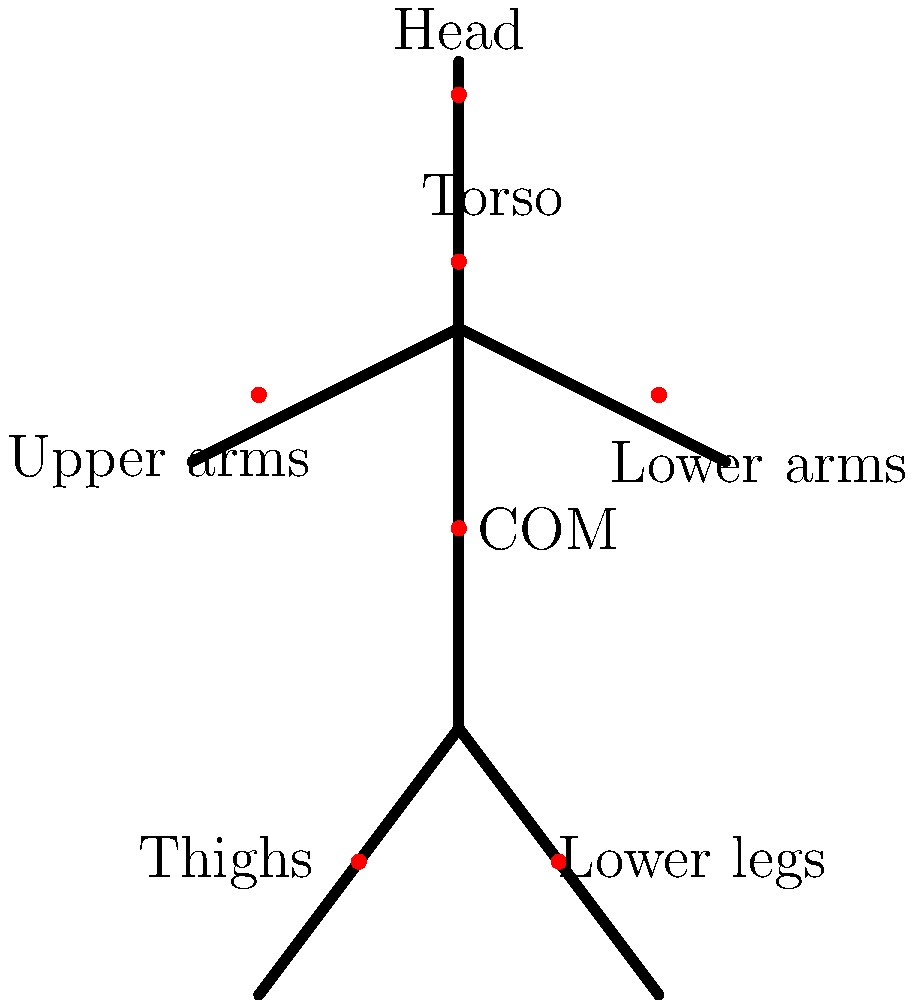In a simplified human body model for biomechanical analysis, the center of mass (COM) of each body segment is typically represented by a point. Given the following mass percentages for each body segment:

- Head: 8%
- Torso: 50%
- Upper arms (each): 3%
- Lower arms (each): 2%
- Thighs (each): 10%
- Lower legs (each): 6%

Calculate the vertical distance of the whole-body COM from the ground for a person standing upright, assuming the total height is 180 cm and the following vertical positions for each segment's COM (measured from the ground up):

- Head COM: 95% of total height
- Torso COM: 70% of total height
- Upper arms COM: 50% of total height
- Lower arms COM: 50% of total height
- Thighs COM: 20% of total height
- Lower legs COM: 20% of total height

Express your answer as a percentage of the total height. To solve this problem, we'll follow these steps:

1. Calculate the height of each segment's COM:
   - Head: $0.95 \times 180 = 171$ cm
   - Torso: $0.70 \times 180 = 126$ cm
   - Upper arms: $0.50 \times 180 = 90$ cm
   - Lower arms: $0.50 \times 180 = 90$ cm
   - Thighs: $0.20 \times 180 = 36$ cm
   - Lower legs: $0.20 \times 180 = 36$ cm

2. Multiply each segment's COM height by its mass percentage:
   - Head: $171 \times 0.08 = 13.68$ cm
   - Torso: $126 \times 0.50 = 63$ cm
   - Upper arms: $90 \times (0.03 \times 2) = 5.4$ cm
   - Lower arms: $90 \times (0.02 \times 2) = 3.6$ cm
   - Thighs: $36 \times (0.10 \times 2) = 7.2$ cm
   - Lower legs: $36 \times (0.06 \times 2) = 4.32$ cm

3. Sum up all the weighted heights:
   $13.68 + 63 + 5.4 + 3.6 + 7.2 + 4.32 = 97.2$ cm

4. Calculate the percentage of total height:
   $(97.2 \text{ cm} ÷ 180 \text{ cm}) \times 100\% = 54\%$

Therefore, the whole-body COM is located at 54% of the total height from the ground.
Answer: 54% of total height 